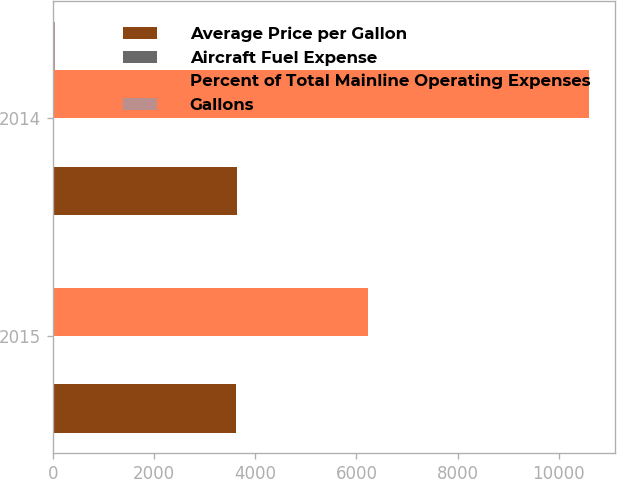Convert chart to OTSL. <chart><loc_0><loc_0><loc_500><loc_500><stacked_bar_chart><ecel><fcel>2015<fcel>2014<nl><fcel>Average Price per Gallon<fcel>3611<fcel>3644<nl><fcel>Aircraft Fuel Expense<fcel>1.72<fcel>2.91<nl><fcel>Percent of Total Mainline Operating Expenses<fcel>6226<fcel>10592<nl><fcel>Gallons<fcel>21.6<fcel>33.2<nl></chart> 